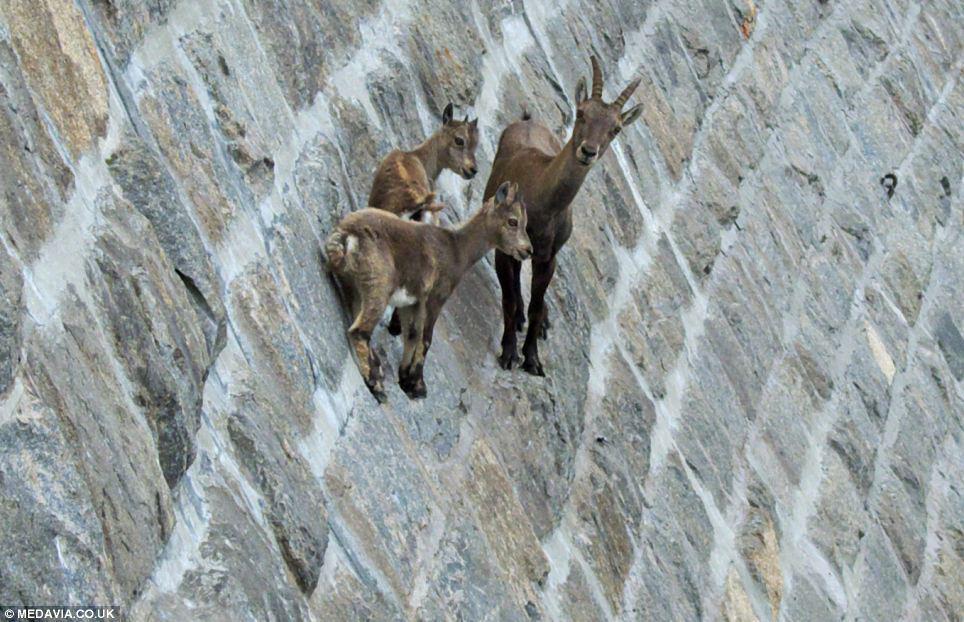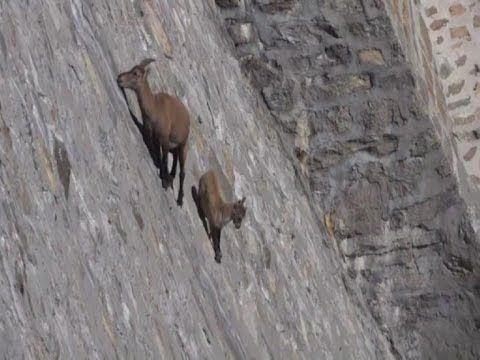The first image is the image on the left, the second image is the image on the right. Analyze the images presented: Is the assertion "The left and right image contains a total of three goat.." valid? Answer yes or no. No. The first image is the image on the left, the second image is the image on the right. Examine the images to the left and right. Is the description "There is a total of three antelopes." accurate? Answer yes or no. No. 